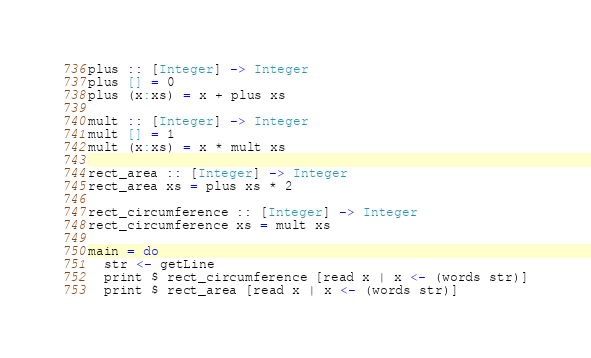<code> <loc_0><loc_0><loc_500><loc_500><_Haskell_>plus :: [Integer] -> Integer
plus [] = 0
plus (x:xs) = x + plus xs

mult :: [Integer] -> Integer
mult [] = 1
mult (x:xs) = x * mult xs

rect_area :: [Integer] -> Integer
rect_area xs = plus xs * 2

rect_circumference :: [Integer] -> Integer
rect_circumference xs = mult xs

main = do
  str <- getLine
  print $ rect_circumference [read x | x <- (words str)]
  print $ rect_area [read x | x <- (words str)]</code> 